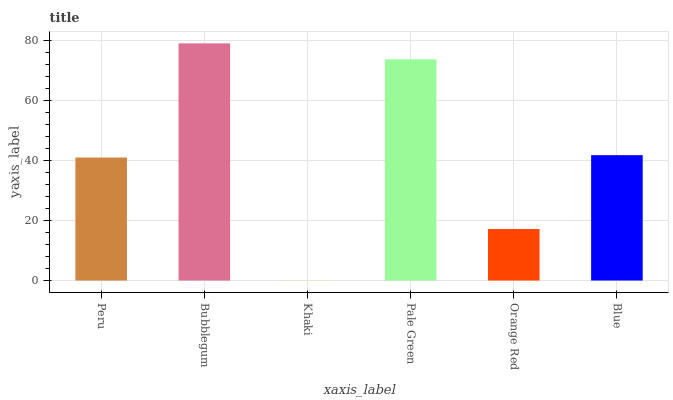Is Khaki the minimum?
Answer yes or no. Yes. Is Bubblegum the maximum?
Answer yes or no. Yes. Is Bubblegum the minimum?
Answer yes or no. No. Is Khaki the maximum?
Answer yes or no. No. Is Bubblegum greater than Khaki?
Answer yes or no. Yes. Is Khaki less than Bubblegum?
Answer yes or no. Yes. Is Khaki greater than Bubblegum?
Answer yes or no. No. Is Bubblegum less than Khaki?
Answer yes or no. No. Is Blue the high median?
Answer yes or no. Yes. Is Peru the low median?
Answer yes or no. Yes. Is Orange Red the high median?
Answer yes or no. No. Is Orange Red the low median?
Answer yes or no. No. 